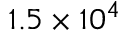<formula> <loc_0><loc_0><loc_500><loc_500>1 . 5 \times 1 0 ^ { 4 }</formula> 